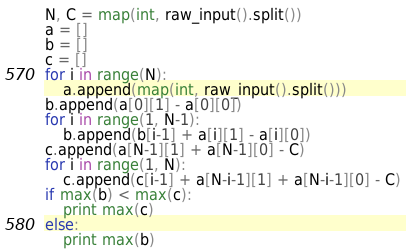Convert code to text. <code><loc_0><loc_0><loc_500><loc_500><_Python_>N, C = map(int, raw_input().split())
a = []
b = []
c = []
for i in range(N):
	a.append(map(int, raw_input().split()))
b.append(a[0][1] - a[0][0])
for i in range(1, N-1):
	b.append(b[i-1] + a[i][1] - a[i][0])
c.append(a[N-1][1] + a[N-1][0] - C)
for i in range(1, N):
	c.append(c[i-1] + a[N-i-1][1] + a[N-i-1][0] - C)
if max(b) < max(c):
	print max(c)
else:
	print max(b)</code> 